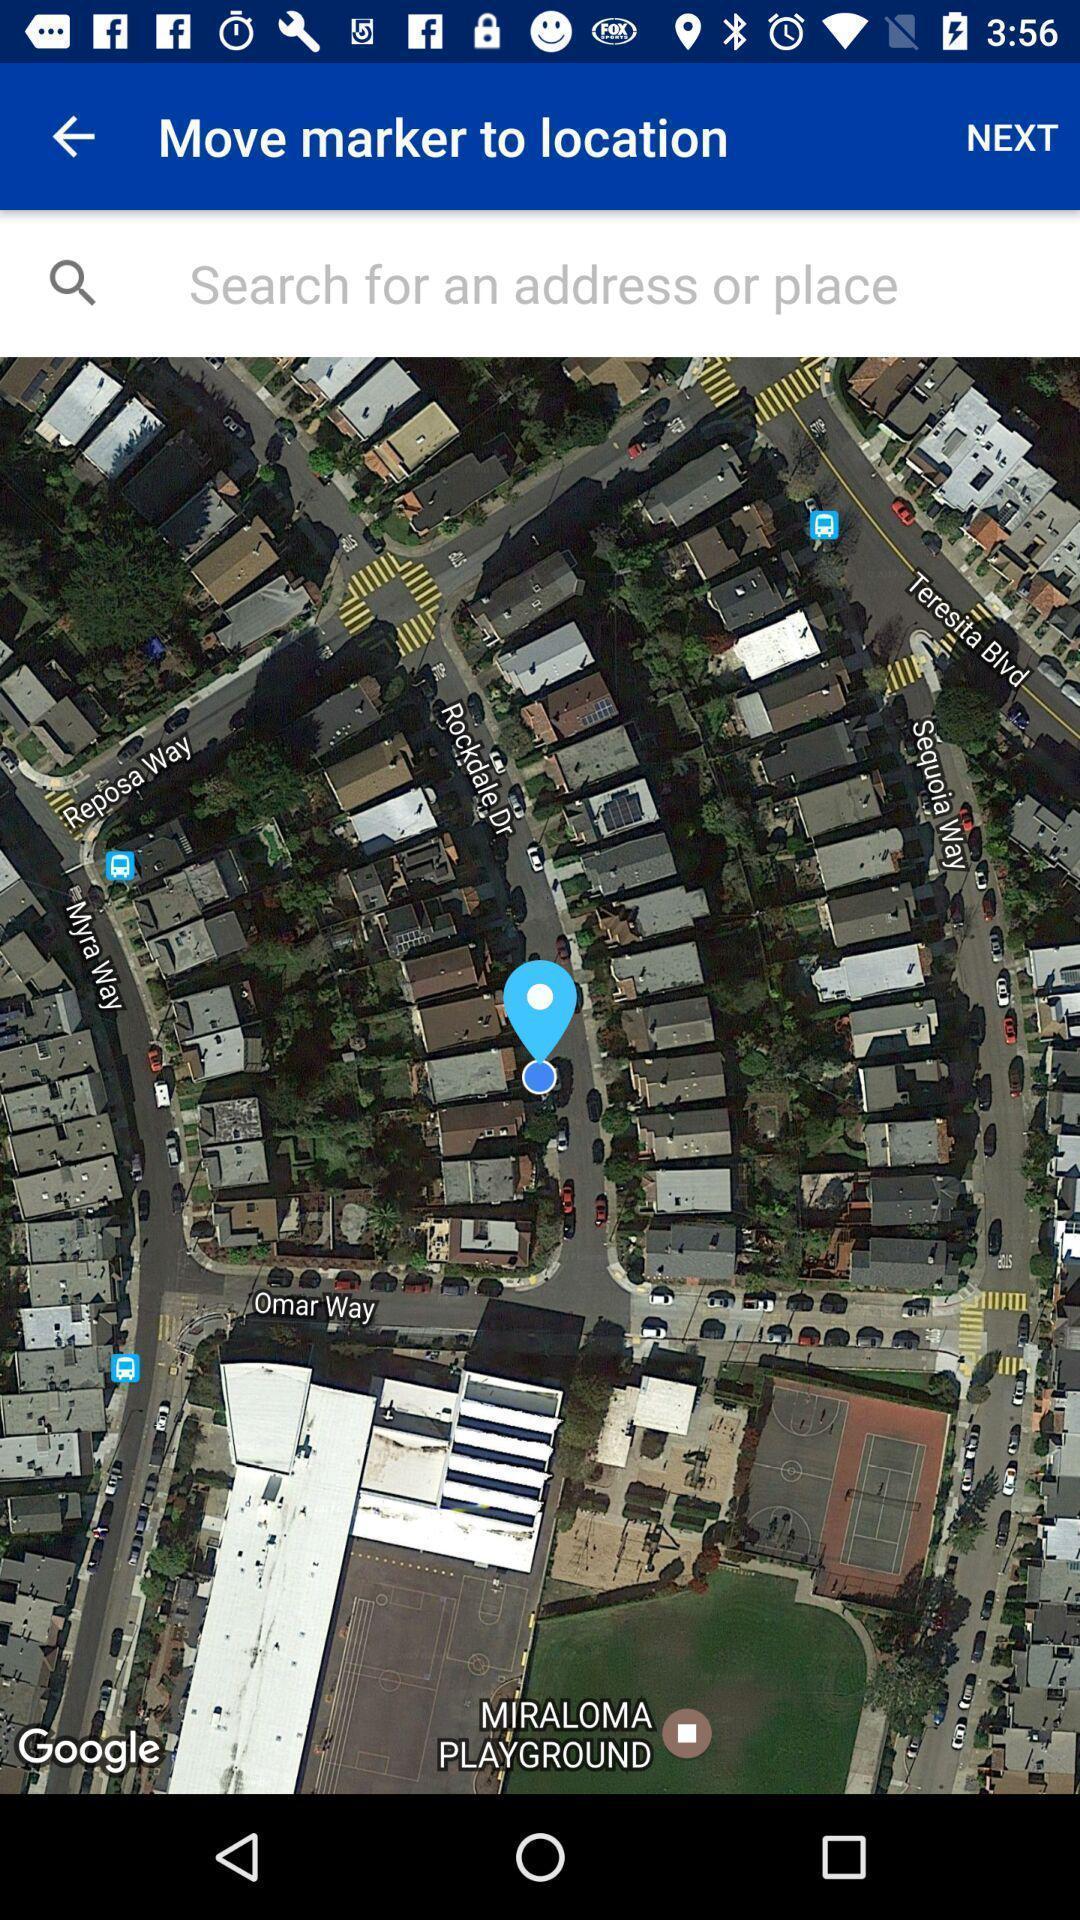Please provide a description for this image. Search bar to find location. 